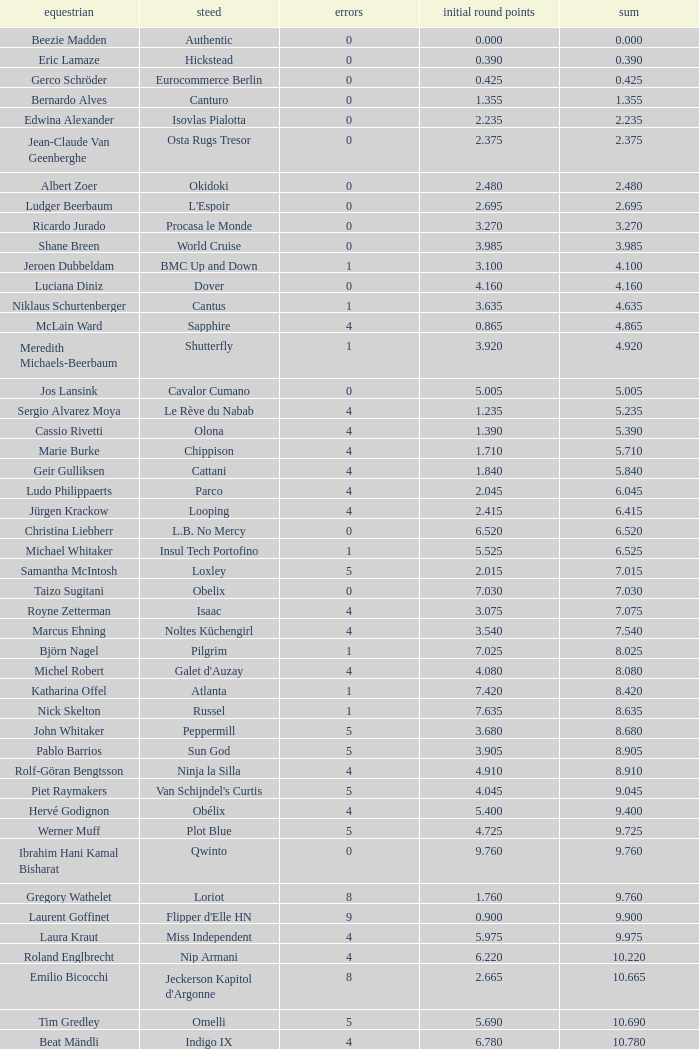Tell me the most total for horse of carlson 29.545. 